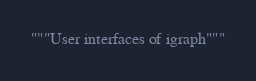<code> <loc_0><loc_0><loc_500><loc_500><_Python_>"""User interfaces of igraph"""

</code> 